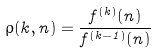Convert formula to latex. <formula><loc_0><loc_0><loc_500><loc_500>\rho ( k , n ) = \frac { f ^ { ( k ) } ( n ) } { f ^ { ( k - 1 ) } ( n ) }</formula> 